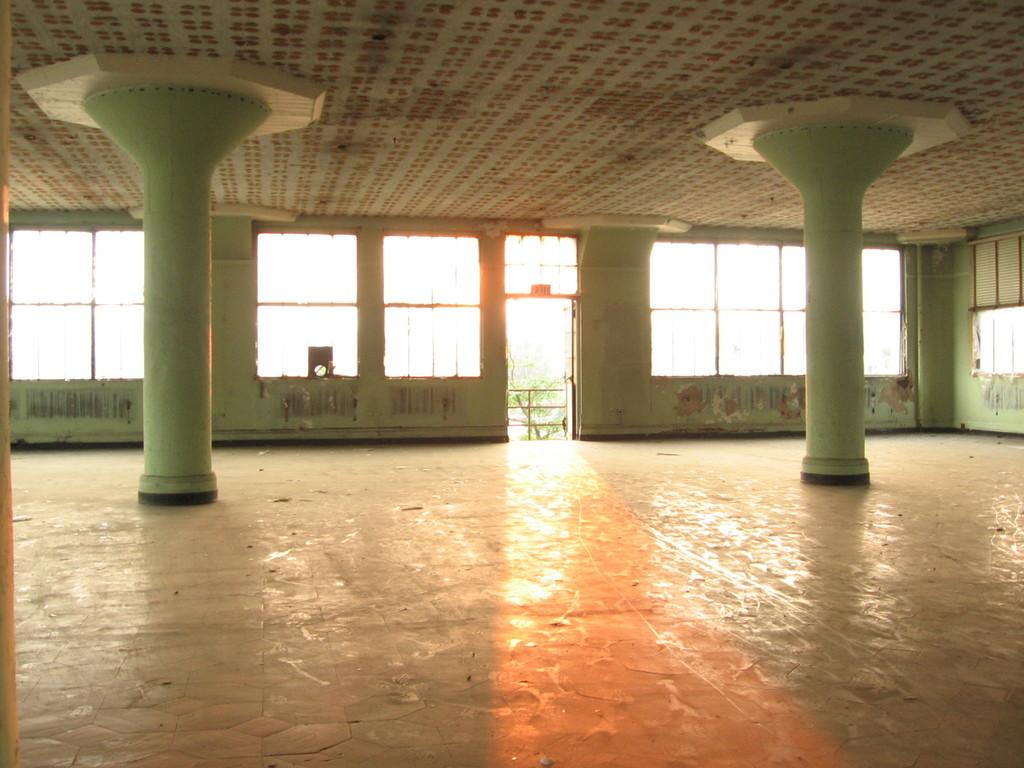What type of architectural elements can be seen in the image? There are pillars and a fence in the image. What natural element is present in the image? There is a tree in the image. What part of a building is visible in the image? There are windows and a roof in the image. Can you see any mountains in the image? There are no mountains present in the image. What type of teeth can be seen in the image? There are no teeth visible in the image. 